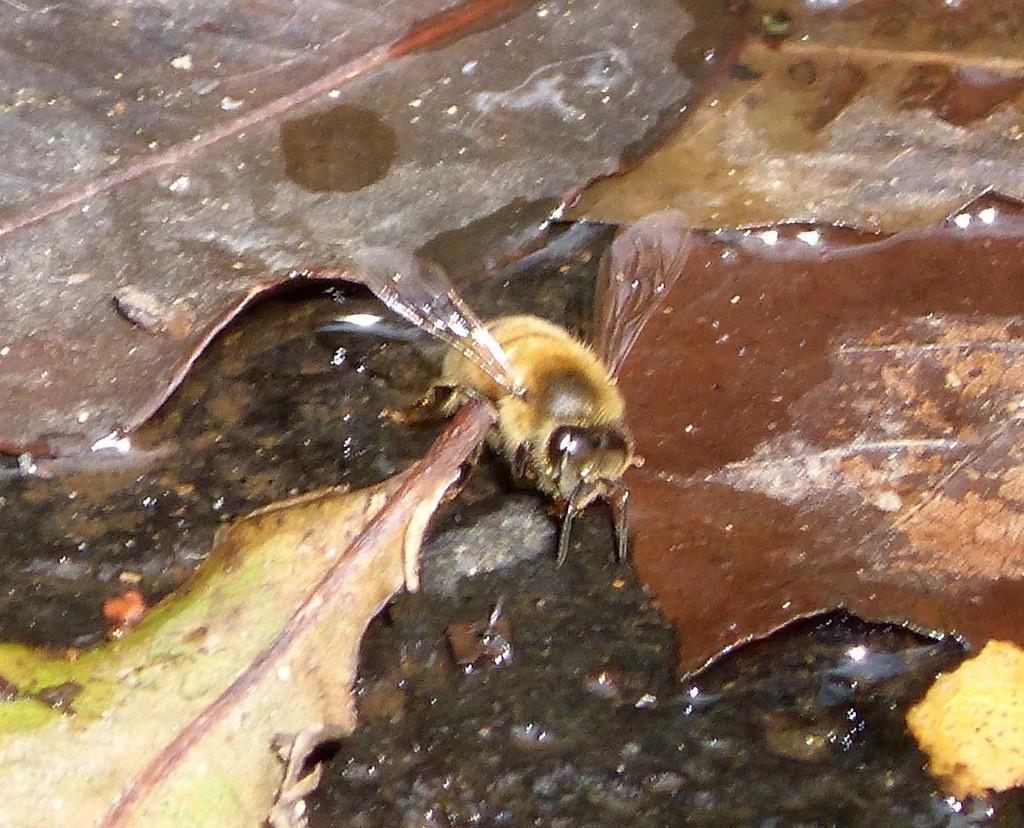Please provide a concise description of this image. In this image we can see a fly on the shredded leaves. 